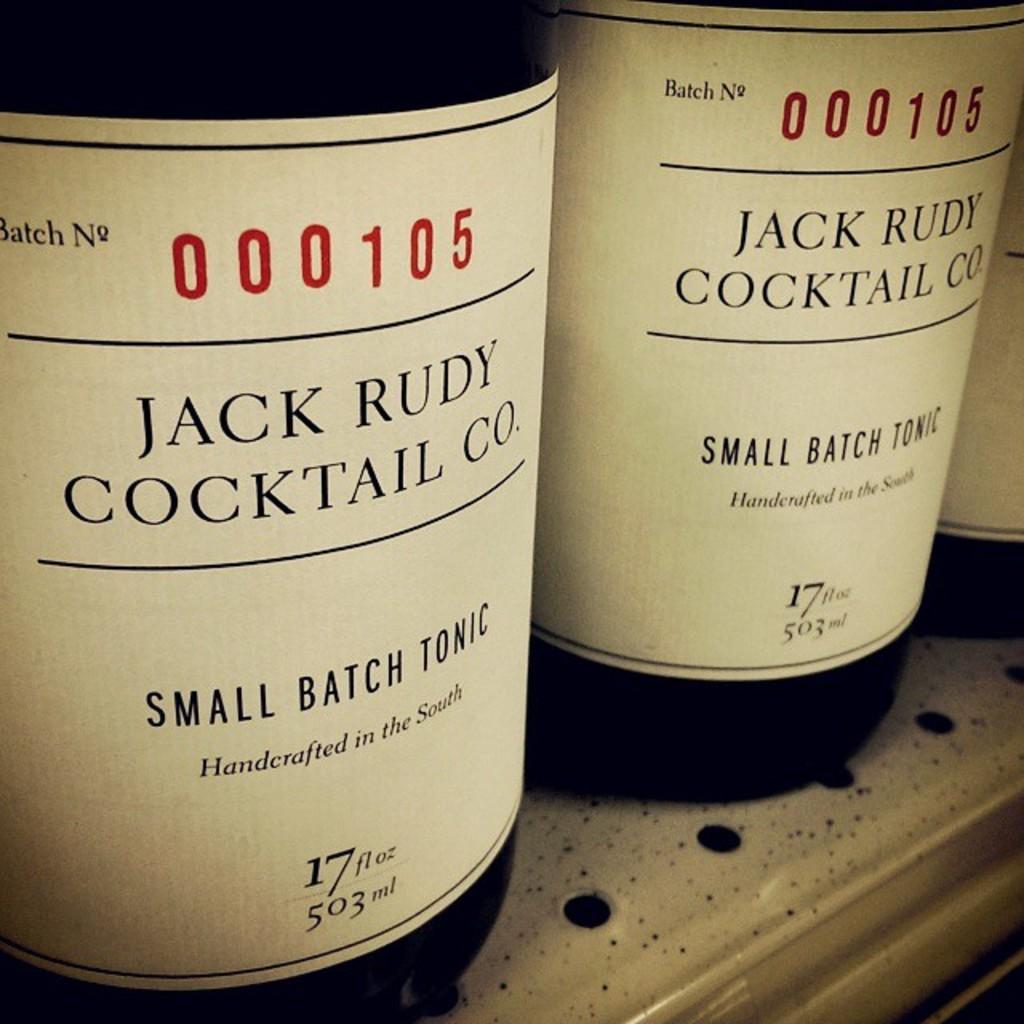Where has this cocktail been handcrafted from?
Offer a very short reply. The south. What's the volume of the bottles?
Offer a very short reply. 503ml. 